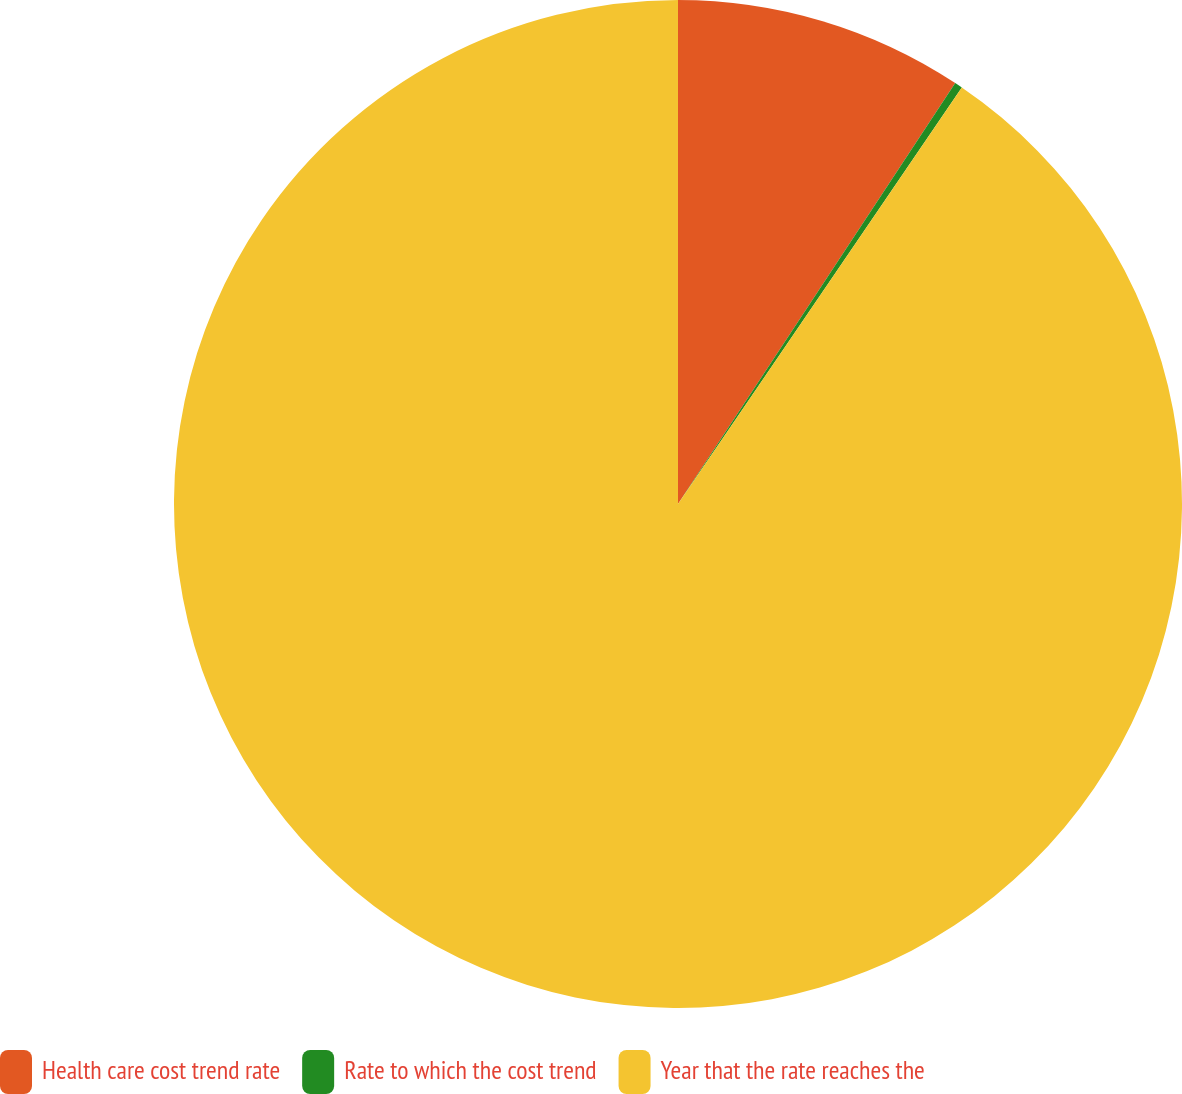<chart> <loc_0><loc_0><loc_500><loc_500><pie_chart><fcel>Health care cost trend rate<fcel>Rate to which the cost trend<fcel>Year that the rate reaches the<nl><fcel>9.27%<fcel>0.25%<fcel>90.48%<nl></chart> 